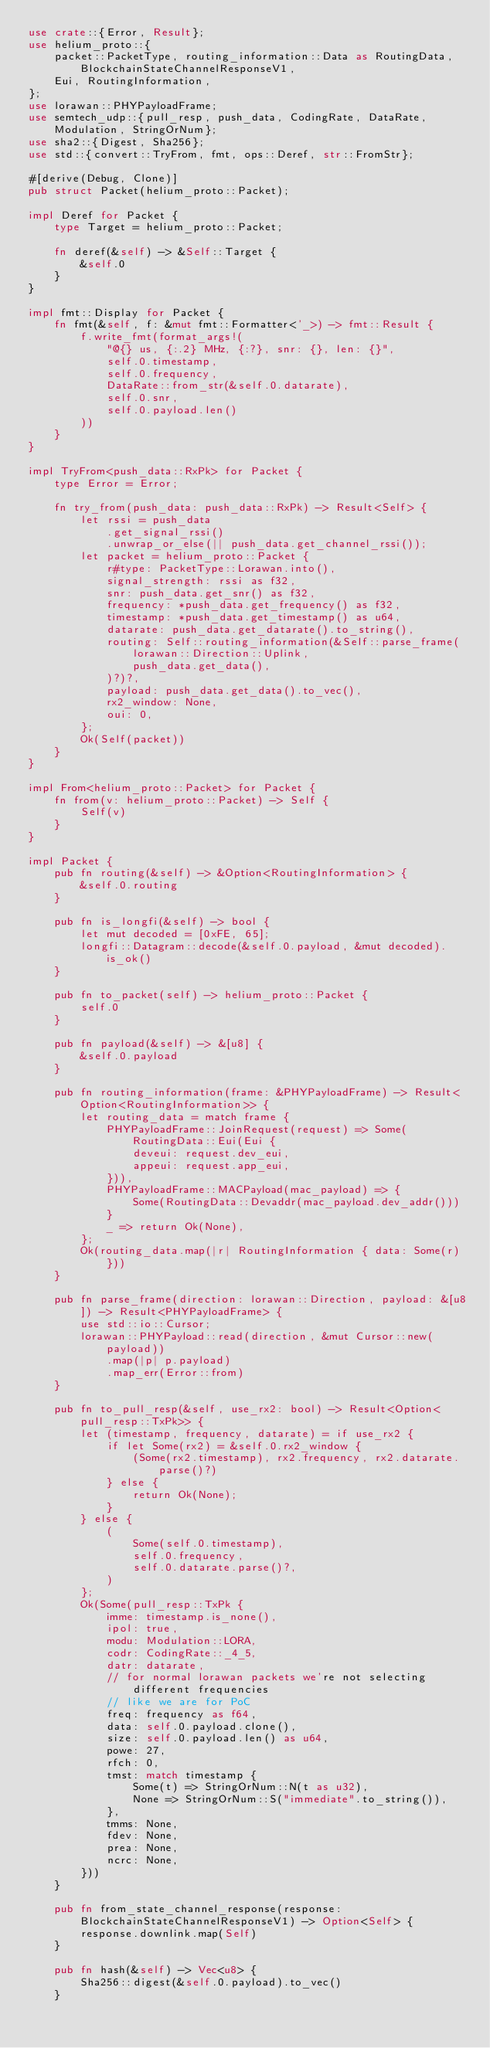<code> <loc_0><loc_0><loc_500><loc_500><_Rust_>use crate::{Error, Result};
use helium_proto::{
    packet::PacketType, routing_information::Data as RoutingData, BlockchainStateChannelResponseV1,
    Eui, RoutingInformation,
};
use lorawan::PHYPayloadFrame;
use semtech_udp::{pull_resp, push_data, CodingRate, DataRate, Modulation, StringOrNum};
use sha2::{Digest, Sha256};
use std::{convert::TryFrom, fmt, ops::Deref, str::FromStr};

#[derive(Debug, Clone)]
pub struct Packet(helium_proto::Packet);

impl Deref for Packet {
    type Target = helium_proto::Packet;

    fn deref(&self) -> &Self::Target {
        &self.0
    }
}

impl fmt::Display for Packet {
    fn fmt(&self, f: &mut fmt::Formatter<'_>) -> fmt::Result {
        f.write_fmt(format_args!(
            "@{} us, {:.2} MHz, {:?}, snr: {}, len: {}",
            self.0.timestamp,
            self.0.frequency,
            DataRate::from_str(&self.0.datarate),
            self.0.snr,
            self.0.payload.len()
        ))
    }
}

impl TryFrom<push_data::RxPk> for Packet {
    type Error = Error;

    fn try_from(push_data: push_data::RxPk) -> Result<Self> {
        let rssi = push_data
            .get_signal_rssi()
            .unwrap_or_else(|| push_data.get_channel_rssi());
        let packet = helium_proto::Packet {
            r#type: PacketType::Lorawan.into(),
            signal_strength: rssi as f32,
            snr: push_data.get_snr() as f32,
            frequency: *push_data.get_frequency() as f32,
            timestamp: *push_data.get_timestamp() as u64,
            datarate: push_data.get_datarate().to_string(),
            routing: Self::routing_information(&Self::parse_frame(
                lorawan::Direction::Uplink,
                push_data.get_data(),
            )?)?,
            payload: push_data.get_data().to_vec(),
            rx2_window: None,
            oui: 0,
        };
        Ok(Self(packet))
    }
}

impl From<helium_proto::Packet> for Packet {
    fn from(v: helium_proto::Packet) -> Self {
        Self(v)
    }
}

impl Packet {
    pub fn routing(&self) -> &Option<RoutingInformation> {
        &self.0.routing
    }

    pub fn is_longfi(&self) -> bool {
        let mut decoded = [0xFE, 65];
        longfi::Datagram::decode(&self.0.payload, &mut decoded).is_ok()
    }

    pub fn to_packet(self) -> helium_proto::Packet {
        self.0
    }

    pub fn payload(&self) -> &[u8] {
        &self.0.payload
    }

    pub fn routing_information(frame: &PHYPayloadFrame) -> Result<Option<RoutingInformation>> {
        let routing_data = match frame {
            PHYPayloadFrame::JoinRequest(request) => Some(RoutingData::Eui(Eui {
                deveui: request.dev_eui,
                appeui: request.app_eui,
            })),
            PHYPayloadFrame::MACPayload(mac_payload) => {
                Some(RoutingData::Devaddr(mac_payload.dev_addr()))
            }
            _ => return Ok(None),
        };
        Ok(routing_data.map(|r| RoutingInformation { data: Some(r) }))
    }

    pub fn parse_frame(direction: lorawan::Direction, payload: &[u8]) -> Result<PHYPayloadFrame> {
        use std::io::Cursor;
        lorawan::PHYPayload::read(direction, &mut Cursor::new(payload))
            .map(|p| p.payload)
            .map_err(Error::from)
    }

    pub fn to_pull_resp(&self, use_rx2: bool) -> Result<Option<pull_resp::TxPk>> {
        let (timestamp, frequency, datarate) = if use_rx2 {
            if let Some(rx2) = &self.0.rx2_window {
                (Some(rx2.timestamp), rx2.frequency, rx2.datarate.parse()?)
            } else {
                return Ok(None);
            }
        } else {
            (
                Some(self.0.timestamp),
                self.0.frequency,
                self.0.datarate.parse()?,
            )
        };
        Ok(Some(pull_resp::TxPk {
            imme: timestamp.is_none(),
            ipol: true,
            modu: Modulation::LORA,
            codr: CodingRate::_4_5,
            datr: datarate,
            // for normal lorawan packets we're not selecting different frequencies
            // like we are for PoC
            freq: frequency as f64,
            data: self.0.payload.clone(),
            size: self.0.payload.len() as u64,
            powe: 27,
            rfch: 0,
            tmst: match timestamp {
                Some(t) => StringOrNum::N(t as u32),
                None => StringOrNum::S("immediate".to_string()),
            },
            tmms: None,
            fdev: None,
            prea: None,
            ncrc: None,
        }))
    }

    pub fn from_state_channel_response(response: BlockchainStateChannelResponseV1) -> Option<Self> {
        response.downlink.map(Self)
    }

    pub fn hash(&self) -> Vec<u8> {
        Sha256::digest(&self.0.payload).to_vec()
    }
</code> 